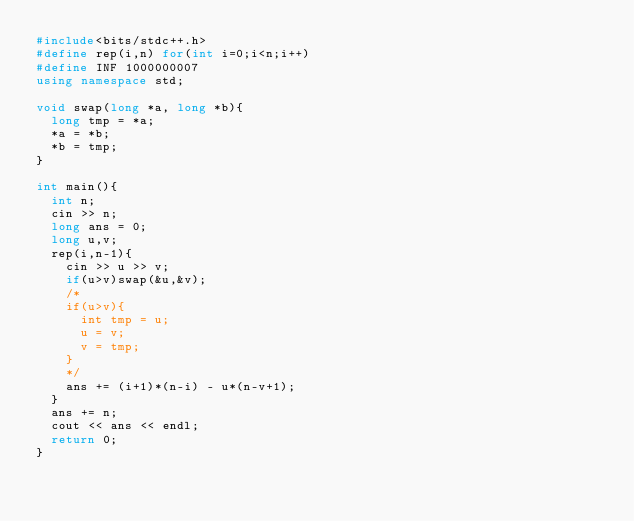<code> <loc_0><loc_0><loc_500><loc_500><_C++_>#include<bits/stdc++.h>
#define rep(i,n) for(int i=0;i<n;i++)
#define INF 1000000007
using namespace std;

void swap(long *a, long *b){
  long tmp = *a;
  *a = *b;
  *b = tmp;
}

int main(){
  int n;
  cin >> n;
  long ans = 0;
  long u,v;
  rep(i,n-1){
    cin >> u >> v;
    if(u>v)swap(&u,&v);
    /*
    if(u>v){
      int tmp = u;
      u = v;
      v = tmp;
    }
    */
    ans += (i+1)*(n-i) - u*(n-v+1);
  }
  ans += n;
  cout << ans << endl;
  return 0;
}</code> 